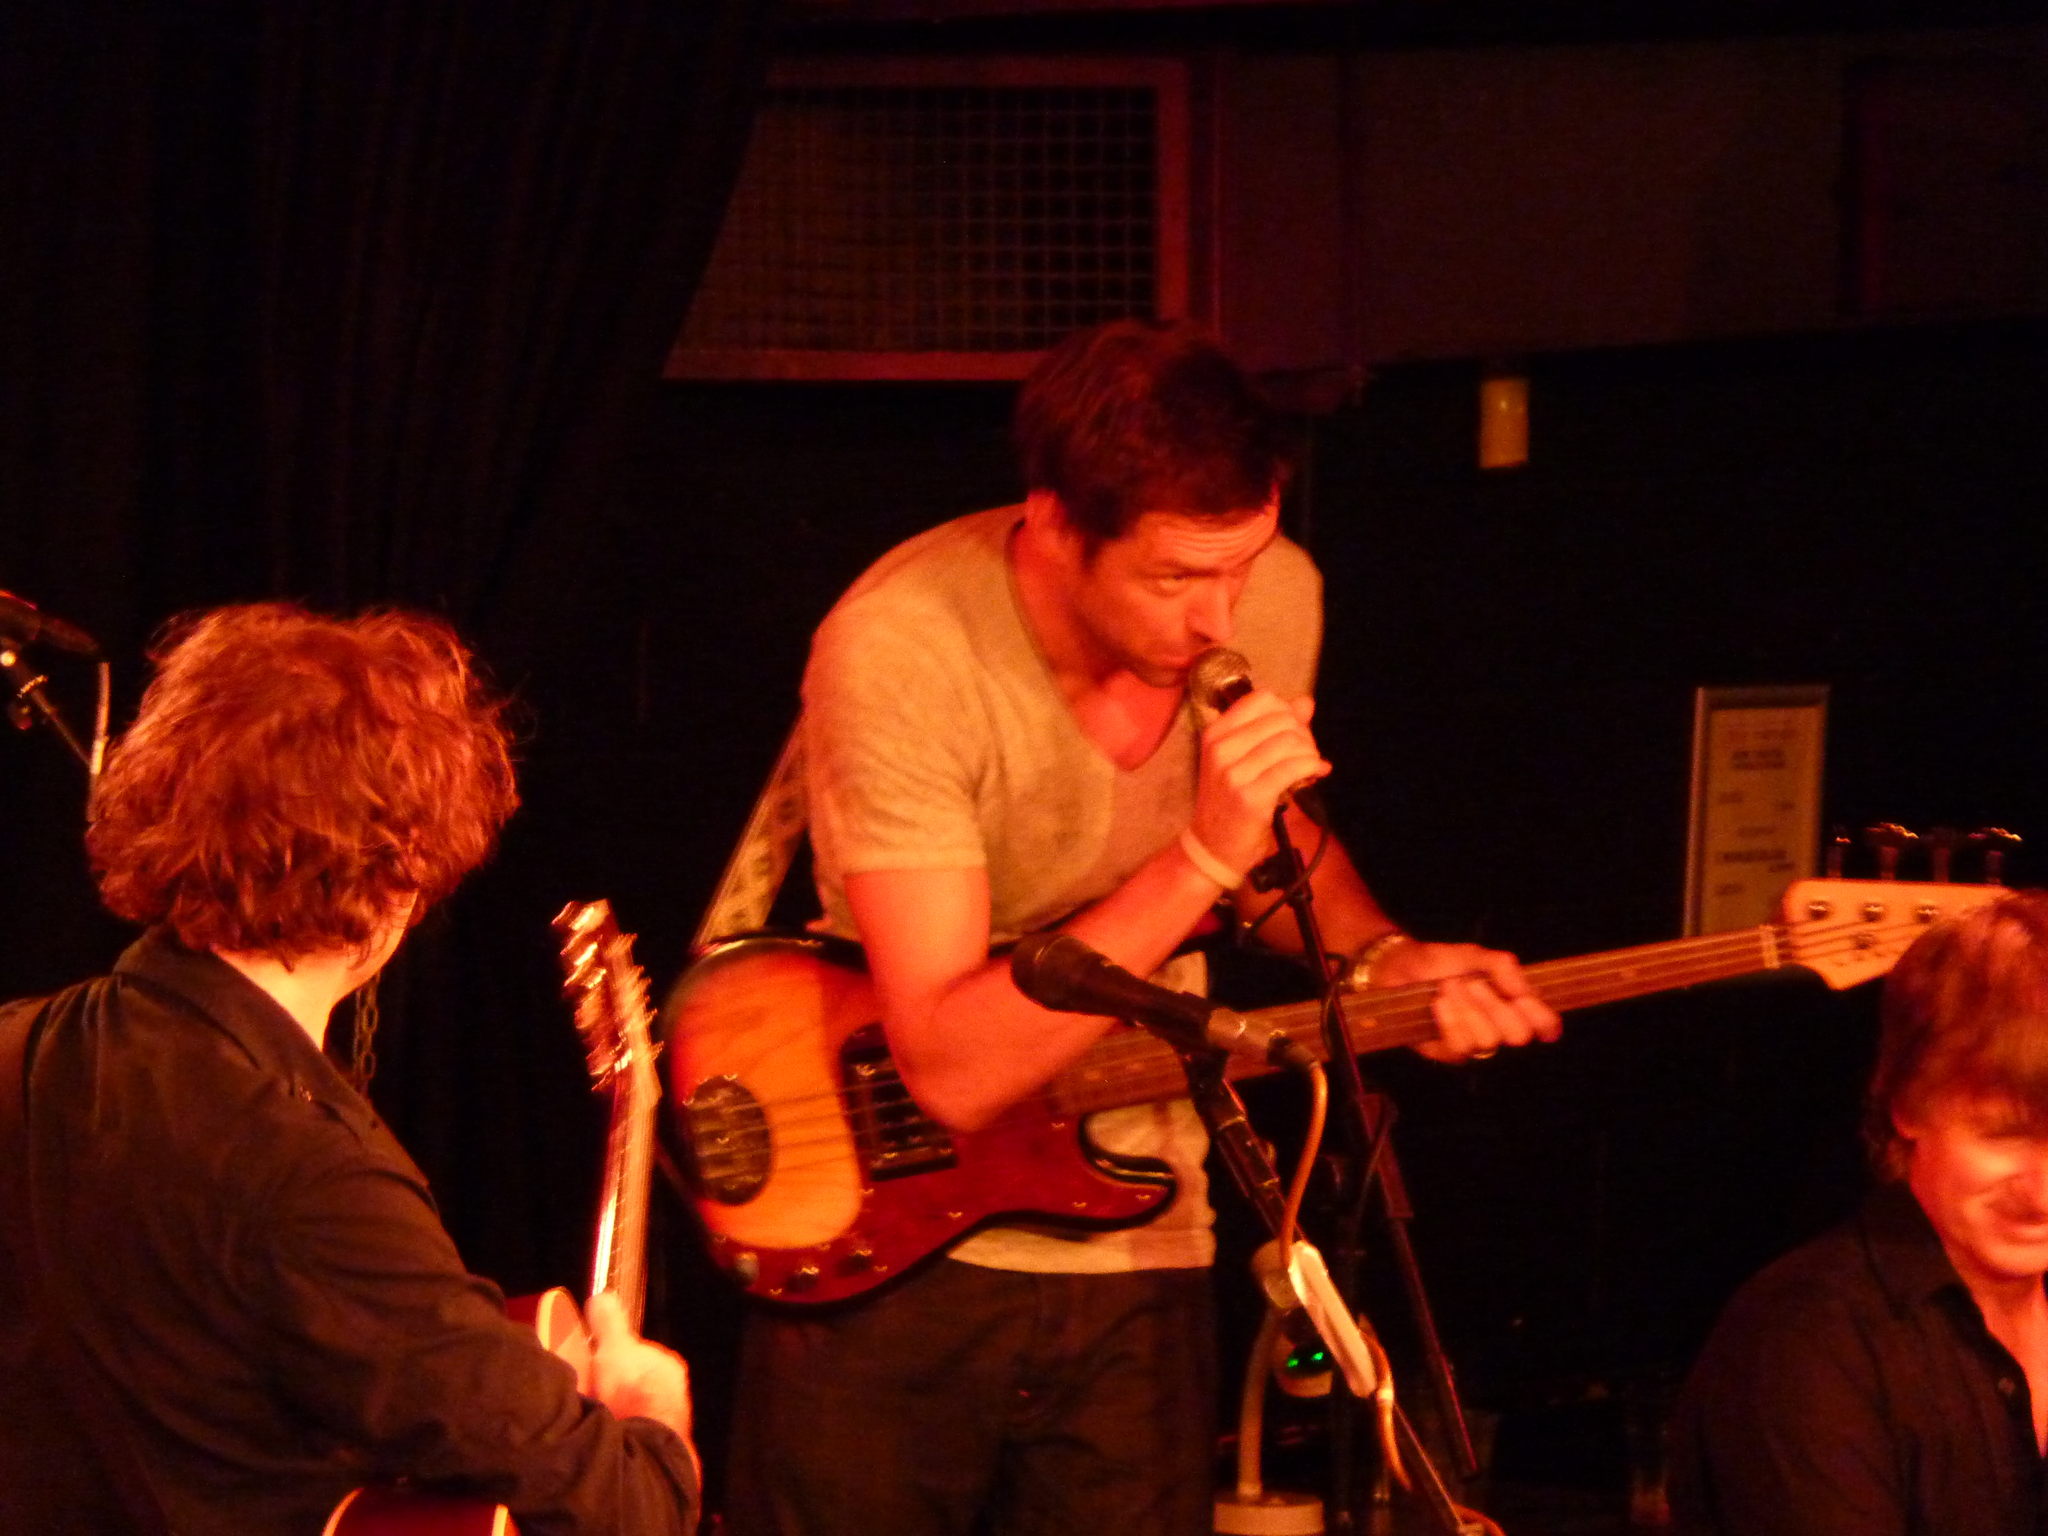Describe this image in one or two sentences. In this image i can see few persons standing and holding guitar in their hands, the person in the middle is holding a microphone in his hand. In the background i can see a black curtain and a microphone. 